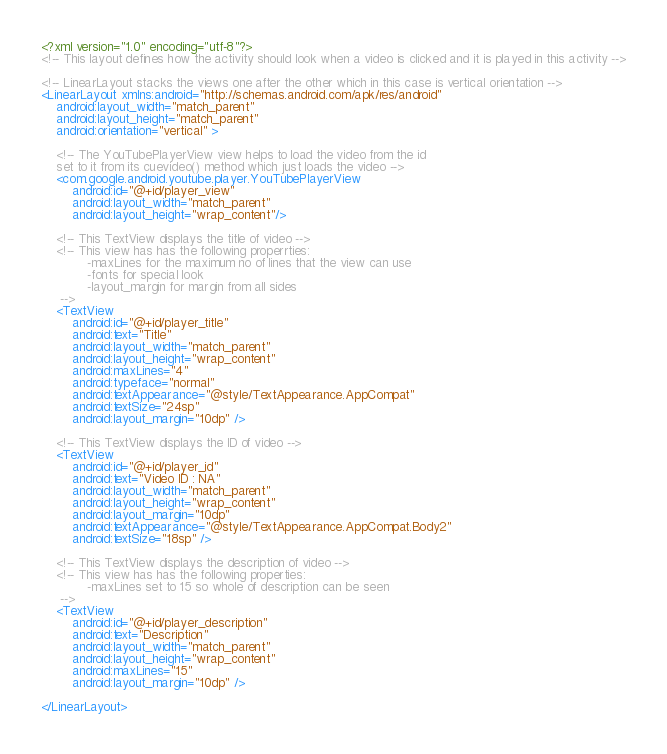Convert code to text. <code><loc_0><loc_0><loc_500><loc_500><_XML_><?xml version="1.0" encoding="utf-8"?>
<!-- This layout defines how the activity should look when a video is clicked and it is played in this activity -->

<!-- LinearLayout stacks the views one after the other which in this case is vertical orientation -->
<LinearLayout xmlns:android="http://schemas.android.com/apk/res/android"
    android:layout_width="match_parent"
    android:layout_height="match_parent"
    android:orientation="vertical" >

    <!-- The YouTubePlayerView view helps to load the video from the id 
    set to it from its cuevideo() method which just loads the video -->
    <com.google.android.youtube.player.YouTubePlayerView
        android:id="@+id/player_view"
        android:layout_width="match_parent"
        android:layout_height="wrap_content"/>

    <!-- This TextView displays the title of video -->
    <!-- This view has has the following properrties:
            -maxLines for the maximum no of lines that the view can use
            -fonts for special look
            -layout_margin for margin from all sides
     -->
    <TextView
        android:id="@+id/player_title"
        android:text="Title"
        android:layout_width="match_parent"
        android:layout_height="wrap_content"
        android:maxLines="4"
        android:typeface="normal"
        android:textAppearance="@style/TextAppearance.AppCompat"
        android:textSize="24sp"
        android:layout_margin="10dp" />

    <!-- This TextView displays the ID of video -->
    <TextView
        android:id="@+id/player_id"
        android:text="Video ID : NA"
        android:layout_width="match_parent"
        android:layout_height="wrap_content"
        android:layout_margin="10dp"
        android:textAppearance="@style/TextAppearance.AppCompat.Body2"
        android:textSize="18sp" />

    <!-- This TextView displays the description of video -->
    <!-- This view has has the following properties:
            -maxLines set to 15 so whole of description can be seen
     -->
    <TextView
        android:id="@+id/player_description"
        android:text="Description"
        android:layout_width="match_parent"
        android:layout_height="wrap_content"
        android:maxLines="15"
        android:layout_margin="10dp" />

</LinearLayout>
</code> 